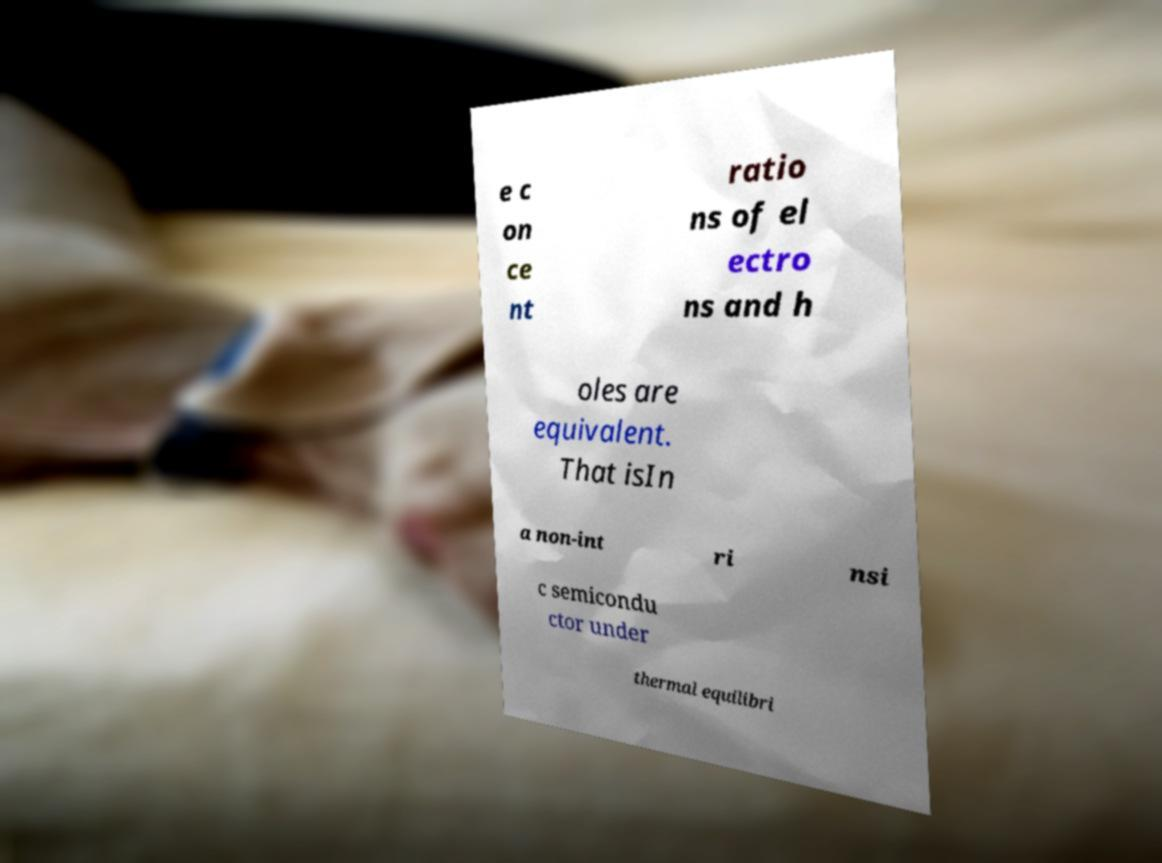Can you read and provide the text displayed in the image?This photo seems to have some interesting text. Can you extract and type it out for me? e c on ce nt ratio ns of el ectro ns and h oles are equivalent. That isIn a non-int ri nsi c semicondu ctor under thermal equilibri 